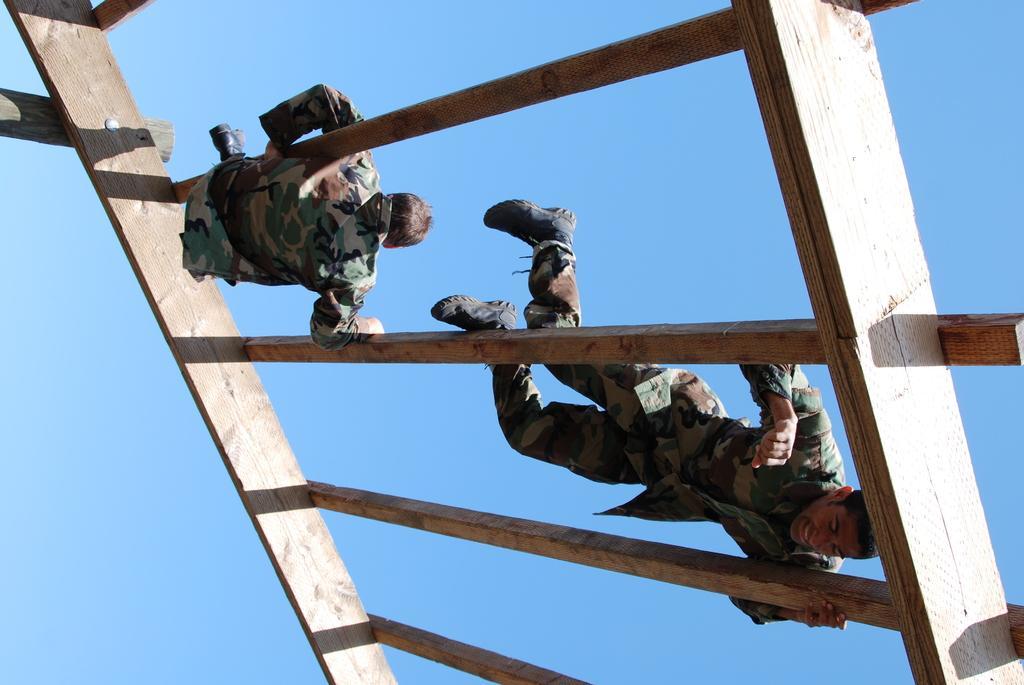How would you summarize this image in a sentence or two? In this image, we can see two persons on wooden material. In the background, we can see the sky. 